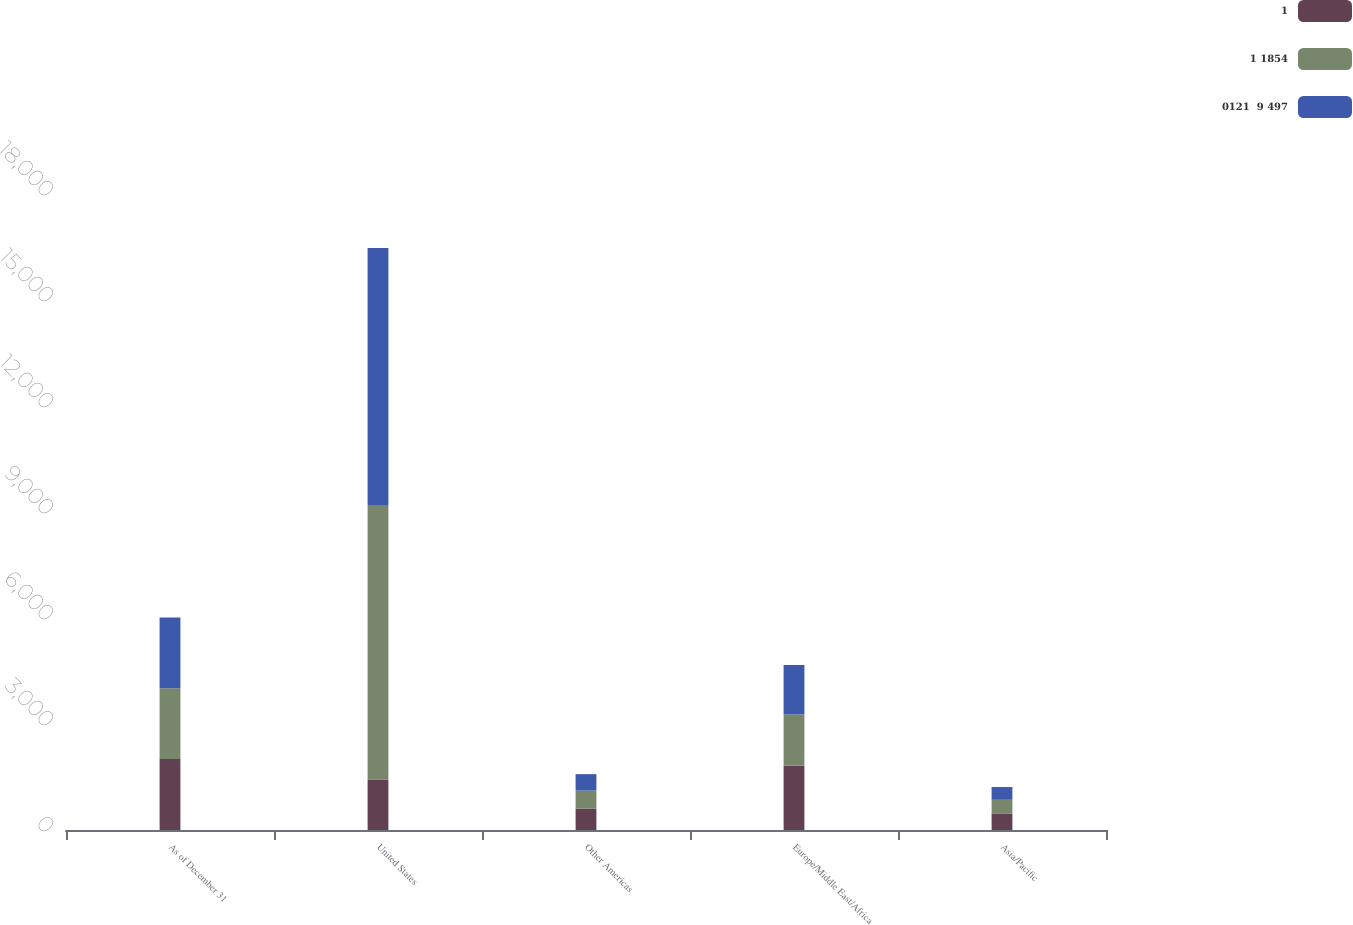Convert chart. <chart><loc_0><loc_0><loc_500><loc_500><stacked_bar_chart><ecel><fcel>As of December 31<fcel>United States<fcel>Other Americas<fcel>Europe/Middle East/Africa<fcel>Asia/Pacific<nl><fcel>1<fcel>2006<fcel>1428.5<fcel>607<fcel>1815<fcel>470<nl><fcel>1 1854<fcel>2005<fcel>7773<fcel>508<fcel>1454<fcel>386<nl><fcel>0121  9 497<fcel>2004<fcel>7268<fcel>466<fcel>1403<fcel>360<nl></chart> 